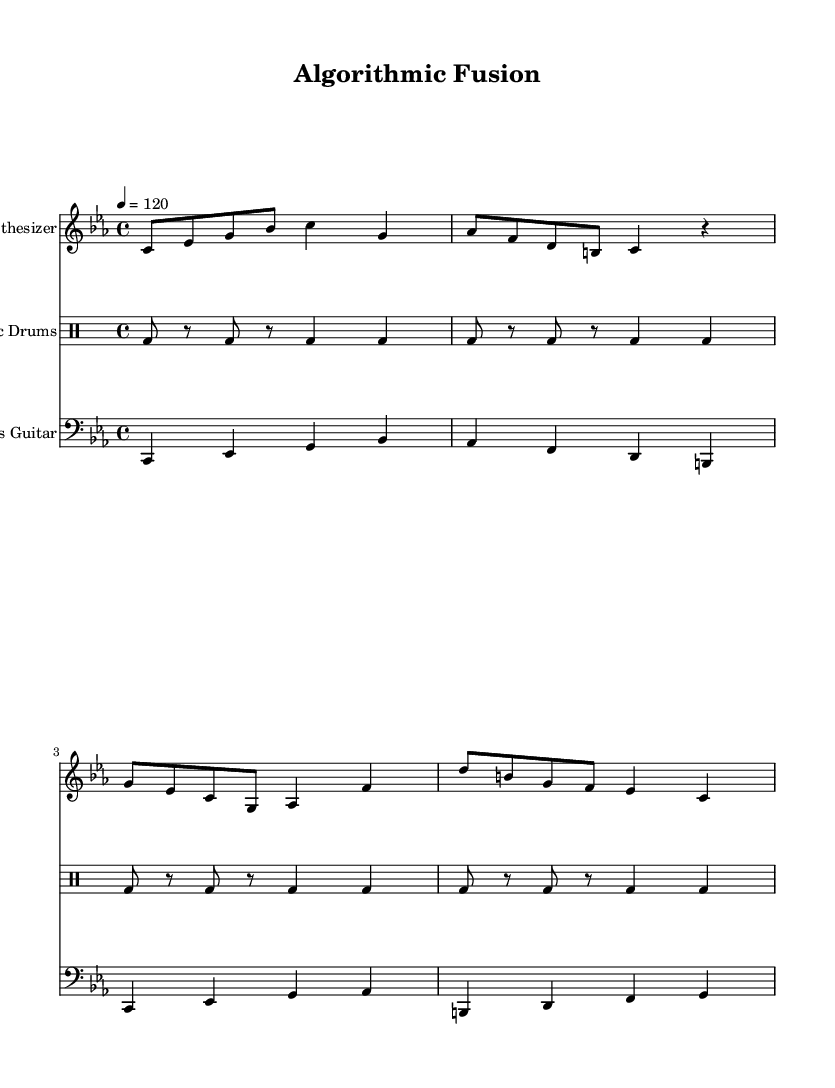What is the key signature of this music? The key signature is C minor, which is indicated by three flats in the key signature area.
Answer: C minor What is the time signature of the piece? The time signature is indicated at the beginning of the staff and shows it as 4/4, which means there are four beats in each measure.
Answer: 4/4 What is the tempo marking for this composition? The tempo marking is indicated at the beginning of the score and states that the tempo is one hundred twenty beats per minute.
Answer: 120 How many measures are in the synthesizer part? Counting the measures in the synthesizer part, there are four distinct measures indicated by vertical lines.
Answer: 4 What instruments are featured in this piece? The instruments are identified at the beginning of their respective staffs. The piece includes a synthesizer, electronic drums, and a bass guitar.
Answer: Synthesizer, Electronic Drums, Bass Guitar Which instrument plays the main melody? The synthesizer, as indicated by the instrument name, features a melodic line that plays a sequence of notes distinctive to melodies.
Answer: Synthesizer What effect does the electronic drums have in this composition? The electronic drums provide a consistent rhythmic background that supports the synthesizer and bass guitar, giving an experimental vibe.
Answer: Supports rhythm 